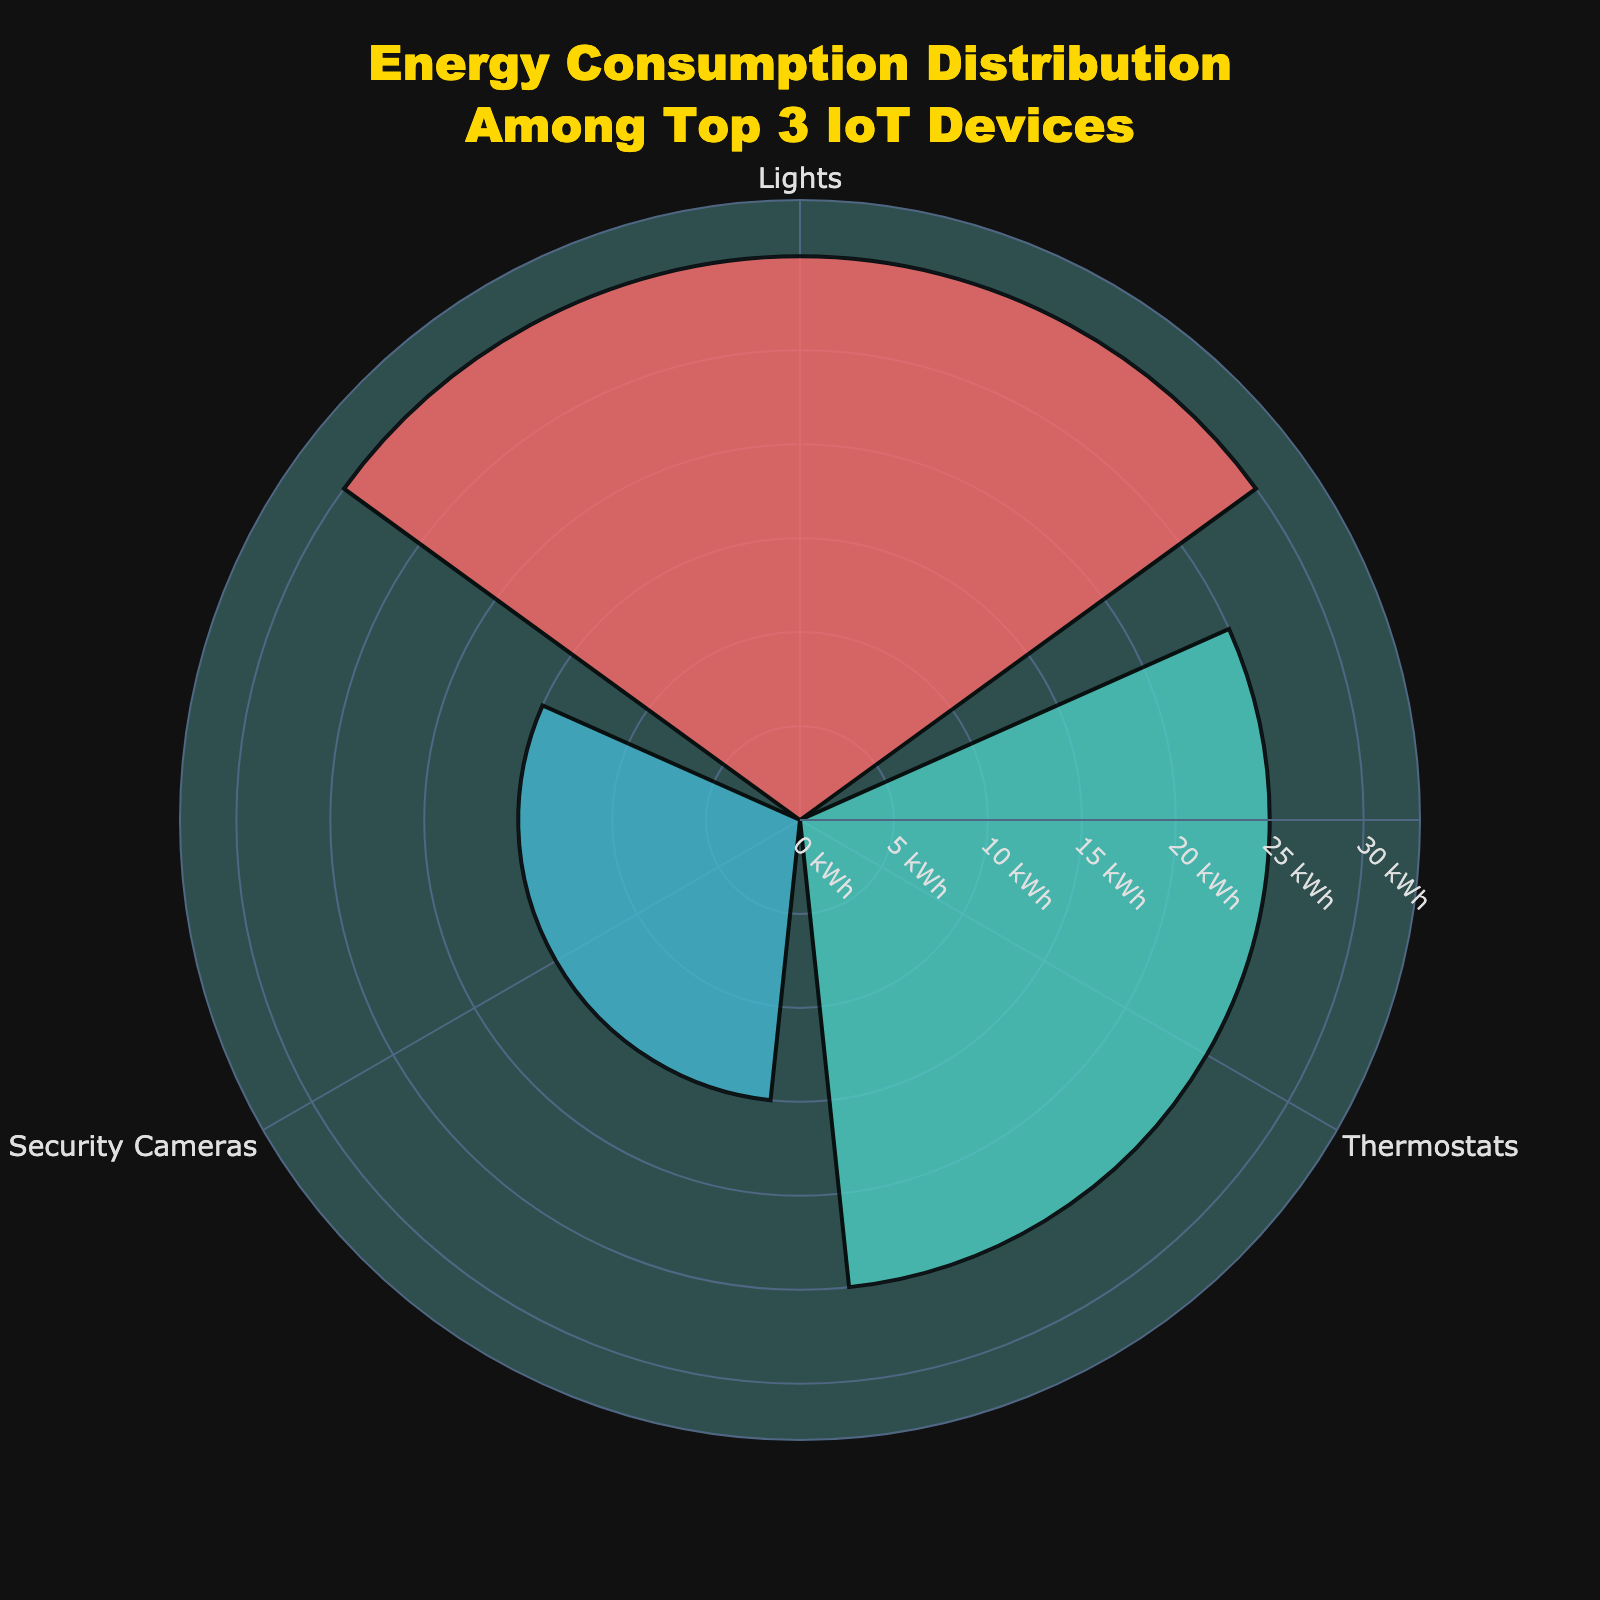What's the title of the figure? The title can be found at the top of the chart, and it reads "Energy Consumption Distribution Among Top 3 IoT Devices".
Answer: Energy Consumption Distribution Among Top 3 IoT Devices Which IoT device has the highest energy consumption? By looking at the lengths of the bars and the labels, the 'Lights' bar is the longest, indicating it has the highest energy consumption.
Answer: Lights What's the combined energy consumption of the 'Thermostats' and 'Security Cameras'? The energy consumption of 'Thermostats' is 25 kWh, and that of 'Security Cameras' is 15 kWh. Adding these values together results in 40 kWh.
Answer: 40 kWh What is the range of energy consumption shown on the radial axis? The radial axis ranges from 0 to a little above the highest value, which in this case is from 0 to roughly 33 kWh.
Answer: 0 to 33 kWh How much more energy does the 'Lights' device consume compared to 'Security Cameras'? The energy consumption of 'Lights' is 30 kWh, and for 'Security Cameras', it is 15 kWh. Subtracting these values gives 15 kWh.
Answer: 15 kWh Which color represents the 'Thermostats'? By matching the colors with the labels, 'Thermostats' is represented by cyan.
Answer: Cyan What percentage of the total energy consumption among the top 3 devices is used by 'Lights'? The total energy consumption of the top 3 devices is 30 (Lights) + 25 (Thermostats) + 15 (Security Cameras) = 70 kWh. The percentage for 'Lights' is (30 / 70) * 100 ≈ 42.86%.
Answer: 42.86% Is the energy consumption of 'Security Cameras' more or less than half of 'Lights'? The energy consumption of 'Lights' is 30 kWh, and half of this value is 15 kWh. Since 'Security Cameras' also use 15 kWh, it is exactly half of 'Lights'.
Answer: Exactly half What are the three devices displayed in the figure? The three devices are indicated by the labels on the radial axis, which are 'Lights', 'Thermostats', and 'Security Cameras'.
Answer: Lights, Thermostats, and Security Cameras What is the energy consumption difference between the highest and lowest values displayed? The highest energy consumption is 'Lights' with 30 kWh, the lowest is 'Security Cameras' with 15 kWh. The difference is 30 - 15 = 15 kWh.
Answer: 15 kWh 